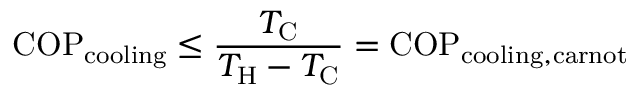<formula> <loc_0><loc_0><loc_500><loc_500>C O P _ { c o o l i n g } \leq { \frac { T _ { C } } { T _ { H } - T _ { C } } } = C O P _ { c o o l i n g , c a r n o t }</formula> 